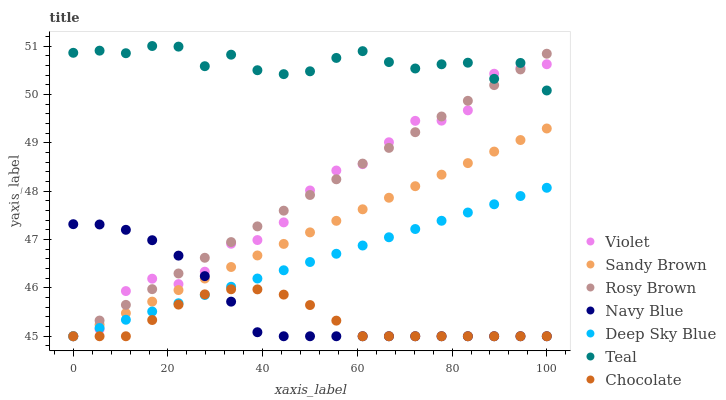Does Chocolate have the minimum area under the curve?
Answer yes or no. Yes. Does Teal have the maximum area under the curve?
Answer yes or no. Yes. Does Navy Blue have the minimum area under the curve?
Answer yes or no. No. Does Navy Blue have the maximum area under the curve?
Answer yes or no. No. Is Deep Sky Blue the smoothest?
Answer yes or no. Yes. Is Violet the roughest?
Answer yes or no. Yes. Is Navy Blue the smoothest?
Answer yes or no. No. Is Navy Blue the roughest?
Answer yes or no. No. Does Deep Sky Blue have the lowest value?
Answer yes or no. Yes. Does Teal have the lowest value?
Answer yes or no. No. Does Teal have the highest value?
Answer yes or no. Yes. Does Navy Blue have the highest value?
Answer yes or no. No. Is Deep Sky Blue less than Teal?
Answer yes or no. Yes. Is Teal greater than Chocolate?
Answer yes or no. Yes. Does Violet intersect Navy Blue?
Answer yes or no. Yes. Is Violet less than Navy Blue?
Answer yes or no. No. Is Violet greater than Navy Blue?
Answer yes or no. No. Does Deep Sky Blue intersect Teal?
Answer yes or no. No. 